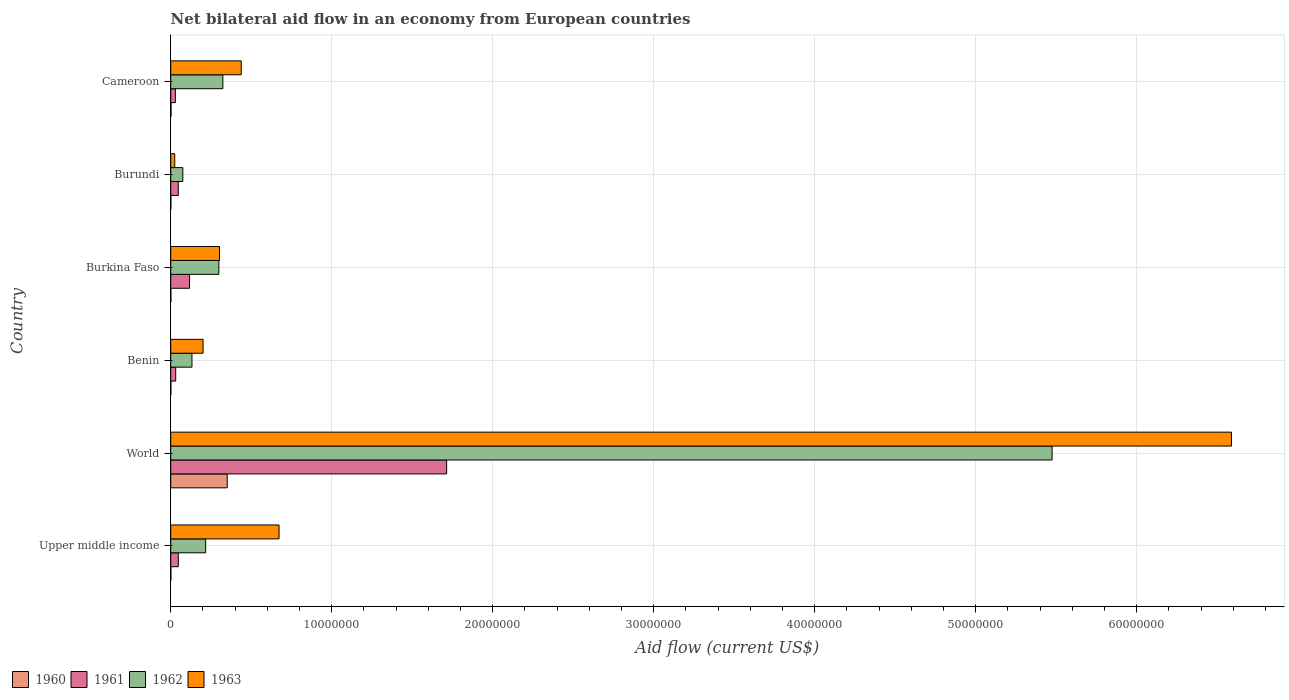How many groups of bars are there?
Offer a very short reply. 6. In how many cases, is the number of bars for a given country not equal to the number of legend labels?
Offer a very short reply. 0. Across all countries, what is the maximum net bilateral aid flow in 1961?
Provide a succinct answer. 1.71e+07. Across all countries, what is the minimum net bilateral aid flow in 1961?
Provide a short and direct response. 2.90e+05. In which country was the net bilateral aid flow in 1961 maximum?
Offer a very short reply. World. In which country was the net bilateral aid flow in 1963 minimum?
Ensure brevity in your answer.  Burundi. What is the total net bilateral aid flow in 1961 in the graph?
Offer a very short reply. 1.98e+07. What is the difference between the net bilateral aid flow in 1963 in Benin and that in Burkina Faso?
Make the answer very short. -1.02e+06. What is the difference between the net bilateral aid flow in 1961 in Burkina Faso and the net bilateral aid flow in 1960 in Upper middle income?
Provide a succinct answer. 1.16e+06. What is the average net bilateral aid flow in 1961 per country?
Make the answer very short. 3.31e+06. What is the difference between the net bilateral aid flow in 1963 and net bilateral aid flow in 1960 in Upper middle income?
Provide a succinct answer. 6.72e+06. In how many countries, is the net bilateral aid flow in 1962 greater than 60000000 US$?
Offer a terse response. 0. Is the difference between the net bilateral aid flow in 1963 in Cameroon and Upper middle income greater than the difference between the net bilateral aid flow in 1960 in Cameroon and Upper middle income?
Provide a succinct answer. No. What is the difference between the highest and the second highest net bilateral aid flow in 1961?
Offer a terse response. 1.60e+07. What is the difference between the highest and the lowest net bilateral aid flow in 1961?
Give a very brief answer. 1.68e+07. Is it the case that in every country, the sum of the net bilateral aid flow in 1963 and net bilateral aid flow in 1960 is greater than the sum of net bilateral aid flow in 1962 and net bilateral aid flow in 1961?
Your response must be concise. Yes. What does the 3rd bar from the top in Burundi represents?
Make the answer very short. 1961. What does the 1st bar from the bottom in World represents?
Ensure brevity in your answer.  1960. Is it the case that in every country, the sum of the net bilateral aid flow in 1961 and net bilateral aid flow in 1960 is greater than the net bilateral aid flow in 1963?
Provide a short and direct response. No. Are all the bars in the graph horizontal?
Your answer should be compact. Yes. How many countries are there in the graph?
Your answer should be compact. 6. What is the difference between two consecutive major ticks on the X-axis?
Offer a very short reply. 1.00e+07. Does the graph contain any zero values?
Give a very brief answer. No. Does the graph contain grids?
Offer a very short reply. Yes. Where does the legend appear in the graph?
Your response must be concise. Bottom left. How many legend labels are there?
Make the answer very short. 4. How are the legend labels stacked?
Ensure brevity in your answer.  Horizontal. What is the title of the graph?
Ensure brevity in your answer.  Net bilateral aid flow in an economy from European countries. What is the label or title of the Y-axis?
Your answer should be compact. Country. What is the Aid flow (current US$) of 1962 in Upper middle income?
Your response must be concise. 2.17e+06. What is the Aid flow (current US$) in 1963 in Upper middle income?
Provide a short and direct response. 6.73e+06. What is the Aid flow (current US$) of 1960 in World?
Your answer should be very brief. 3.51e+06. What is the Aid flow (current US$) in 1961 in World?
Provide a succinct answer. 1.71e+07. What is the Aid flow (current US$) of 1962 in World?
Ensure brevity in your answer.  5.48e+07. What is the Aid flow (current US$) of 1963 in World?
Give a very brief answer. 6.59e+07. What is the Aid flow (current US$) in 1962 in Benin?
Your response must be concise. 1.32e+06. What is the Aid flow (current US$) in 1963 in Benin?
Give a very brief answer. 2.01e+06. What is the Aid flow (current US$) in 1960 in Burkina Faso?
Make the answer very short. 10000. What is the Aid flow (current US$) of 1961 in Burkina Faso?
Your response must be concise. 1.17e+06. What is the Aid flow (current US$) of 1962 in Burkina Faso?
Make the answer very short. 2.99e+06. What is the Aid flow (current US$) in 1963 in Burkina Faso?
Give a very brief answer. 3.03e+06. What is the Aid flow (current US$) in 1960 in Burundi?
Offer a terse response. 10000. What is the Aid flow (current US$) of 1962 in Burundi?
Your answer should be compact. 7.50e+05. What is the Aid flow (current US$) in 1961 in Cameroon?
Give a very brief answer. 2.90e+05. What is the Aid flow (current US$) of 1962 in Cameroon?
Make the answer very short. 3.24e+06. What is the Aid flow (current US$) of 1963 in Cameroon?
Offer a terse response. 4.38e+06. Across all countries, what is the maximum Aid flow (current US$) of 1960?
Make the answer very short. 3.51e+06. Across all countries, what is the maximum Aid flow (current US$) in 1961?
Provide a short and direct response. 1.71e+07. Across all countries, what is the maximum Aid flow (current US$) of 1962?
Keep it short and to the point. 5.48e+07. Across all countries, what is the maximum Aid flow (current US$) in 1963?
Keep it short and to the point. 6.59e+07. Across all countries, what is the minimum Aid flow (current US$) of 1961?
Offer a very short reply. 2.90e+05. Across all countries, what is the minimum Aid flow (current US$) in 1962?
Keep it short and to the point. 7.50e+05. Across all countries, what is the minimum Aid flow (current US$) of 1963?
Ensure brevity in your answer.  2.50e+05. What is the total Aid flow (current US$) in 1960 in the graph?
Offer a terse response. 3.57e+06. What is the total Aid flow (current US$) of 1961 in the graph?
Your answer should be very brief. 1.98e+07. What is the total Aid flow (current US$) of 1962 in the graph?
Your response must be concise. 6.52e+07. What is the total Aid flow (current US$) of 1963 in the graph?
Your answer should be compact. 8.23e+07. What is the difference between the Aid flow (current US$) of 1960 in Upper middle income and that in World?
Your answer should be very brief. -3.50e+06. What is the difference between the Aid flow (current US$) of 1961 in Upper middle income and that in World?
Keep it short and to the point. -1.67e+07. What is the difference between the Aid flow (current US$) in 1962 in Upper middle income and that in World?
Your answer should be very brief. -5.26e+07. What is the difference between the Aid flow (current US$) of 1963 in Upper middle income and that in World?
Your response must be concise. -5.92e+07. What is the difference between the Aid flow (current US$) in 1960 in Upper middle income and that in Benin?
Your answer should be very brief. 0. What is the difference between the Aid flow (current US$) in 1962 in Upper middle income and that in Benin?
Ensure brevity in your answer.  8.50e+05. What is the difference between the Aid flow (current US$) of 1963 in Upper middle income and that in Benin?
Your response must be concise. 4.72e+06. What is the difference between the Aid flow (current US$) of 1961 in Upper middle income and that in Burkina Faso?
Ensure brevity in your answer.  -7.00e+05. What is the difference between the Aid flow (current US$) in 1962 in Upper middle income and that in Burkina Faso?
Ensure brevity in your answer.  -8.20e+05. What is the difference between the Aid flow (current US$) in 1963 in Upper middle income and that in Burkina Faso?
Offer a terse response. 3.70e+06. What is the difference between the Aid flow (current US$) in 1960 in Upper middle income and that in Burundi?
Your answer should be very brief. 0. What is the difference between the Aid flow (current US$) in 1962 in Upper middle income and that in Burundi?
Offer a very short reply. 1.42e+06. What is the difference between the Aid flow (current US$) of 1963 in Upper middle income and that in Burundi?
Give a very brief answer. 6.48e+06. What is the difference between the Aid flow (current US$) of 1961 in Upper middle income and that in Cameroon?
Keep it short and to the point. 1.80e+05. What is the difference between the Aid flow (current US$) in 1962 in Upper middle income and that in Cameroon?
Offer a very short reply. -1.07e+06. What is the difference between the Aid flow (current US$) in 1963 in Upper middle income and that in Cameroon?
Give a very brief answer. 2.35e+06. What is the difference between the Aid flow (current US$) in 1960 in World and that in Benin?
Provide a succinct answer. 3.50e+06. What is the difference between the Aid flow (current US$) in 1961 in World and that in Benin?
Make the answer very short. 1.68e+07. What is the difference between the Aid flow (current US$) of 1962 in World and that in Benin?
Provide a short and direct response. 5.34e+07. What is the difference between the Aid flow (current US$) of 1963 in World and that in Benin?
Your answer should be very brief. 6.39e+07. What is the difference between the Aid flow (current US$) in 1960 in World and that in Burkina Faso?
Your response must be concise. 3.50e+06. What is the difference between the Aid flow (current US$) in 1961 in World and that in Burkina Faso?
Ensure brevity in your answer.  1.60e+07. What is the difference between the Aid flow (current US$) of 1962 in World and that in Burkina Faso?
Ensure brevity in your answer.  5.18e+07. What is the difference between the Aid flow (current US$) in 1963 in World and that in Burkina Faso?
Keep it short and to the point. 6.29e+07. What is the difference between the Aid flow (current US$) in 1960 in World and that in Burundi?
Provide a succinct answer. 3.50e+06. What is the difference between the Aid flow (current US$) in 1961 in World and that in Burundi?
Give a very brief answer. 1.67e+07. What is the difference between the Aid flow (current US$) of 1962 in World and that in Burundi?
Make the answer very short. 5.40e+07. What is the difference between the Aid flow (current US$) of 1963 in World and that in Burundi?
Offer a very short reply. 6.56e+07. What is the difference between the Aid flow (current US$) of 1960 in World and that in Cameroon?
Offer a terse response. 3.49e+06. What is the difference between the Aid flow (current US$) in 1961 in World and that in Cameroon?
Provide a succinct answer. 1.68e+07. What is the difference between the Aid flow (current US$) of 1962 in World and that in Cameroon?
Your answer should be compact. 5.15e+07. What is the difference between the Aid flow (current US$) of 1963 in World and that in Cameroon?
Your response must be concise. 6.15e+07. What is the difference between the Aid flow (current US$) in 1960 in Benin and that in Burkina Faso?
Your answer should be compact. 0. What is the difference between the Aid flow (current US$) in 1961 in Benin and that in Burkina Faso?
Your response must be concise. -8.60e+05. What is the difference between the Aid flow (current US$) in 1962 in Benin and that in Burkina Faso?
Offer a terse response. -1.67e+06. What is the difference between the Aid flow (current US$) in 1963 in Benin and that in Burkina Faso?
Ensure brevity in your answer.  -1.02e+06. What is the difference between the Aid flow (current US$) in 1960 in Benin and that in Burundi?
Keep it short and to the point. 0. What is the difference between the Aid flow (current US$) of 1962 in Benin and that in Burundi?
Your response must be concise. 5.70e+05. What is the difference between the Aid flow (current US$) of 1963 in Benin and that in Burundi?
Make the answer very short. 1.76e+06. What is the difference between the Aid flow (current US$) of 1960 in Benin and that in Cameroon?
Offer a very short reply. -10000. What is the difference between the Aid flow (current US$) in 1962 in Benin and that in Cameroon?
Your answer should be very brief. -1.92e+06. What is the difference between the Aid flow (current US$) of 1963 in Benin and that in Cameroon?
Give a very brief answer. -2.37e+06. What is the difference between the Aid flow (current US$) in 1960 in Burkina Faso and that in Burundi?
Ensure brevity in your answer.  0. What is the difference between the Aid flow (current US$) in 1962 in Burkina Faso and that in Burundi?
Offer a terse response. 2.24e+06. What is the difference between the Aid flow (current US$) of 1963 in Burkina Faso and that in Burundi?
Your answer should be very brief. 2.78e+06. What is the difference between the Aid flow (current US$) of 1960 in Burkina Faso and that in Cameroon?
Make the answer very short. -10000. What is the difference between the Aid flow (current US$) in 1961 in Burkina Faso and that in Cameroon?
Provide a short and direct response. 8.80e+05. What is the difference between the Aid flow (current US$) in 1962 in Burkina Faso and that in Cameroon?
Your answer should be very brief. -2.50e+05. What is the difference between the Aid flow (current US$) in 1963 in Burkina Faso and that in Cameroon?
Your response must be concise. -1.35e+06. What is the difference between the Aid flow (current US$) of 1960 in Burundi and that in Cameroon?
Your answer should be compact. -10000. What is the difference between the Aid flow (current US$) of 1961 in Burundi and that in Cameroon?
Provide a succinct answer. 1.80e+05. What is the difference between the Aid flow (current US$) in 1962 in Burundi and that in Cameroon?
Provide a succinct answer. -2.49e+06. What is the difference between the Aid flow (current US$) of 1963 in Burundi and that in Cameroon?
Give a very brief answer. -4.13e+06. What is the difference between the Aid flow (current US$) of 1960 in Upper middle income and the Aid flow (current US$) of 1961 in World?
Offer a terse response. -1.71e+07. What is the difference between the Aid flow (current US$) in 1960 in Upper middle income and the Aid flow (current US$) in 1962 in World?
Provide a short and direct response. -5.47e+07. What is the difference between the Aid flow (current US$) of 1960 in Upper middle income and the Aid flow (current US$) of 1963 in World?
Make the answer very short. -6.59e+07. What is the difference between the Aid flow (current US$) in 1961 in Upper middle income and the Aid flow (current US$) in 1962 in World?
Your answer should be compact. -5.43e+07. What is the difference between the Aid flow (current US$) in 1961 in Upper middle income and the Aid flow (current US$) in 1963 in World?
Give a very brief answer. -6.54e+07. What is the difference between the Aid flow (current US$) of 1962 in Upper middle income and the Aid flow (current US$) of 1963 in World?
Keep it short and to the point. -6.37e+07. What is the difference between the Aid flow (current US$) of 1960 in Upper middle income and the Aid flow (current US$) of 1961 in Benin?
Offer a very short reply. -3.00e+05. What is the difference between the Aid flow (current US$) of 1960 in Upper middle income and the Aid flow (current US$) of 1962 in Benin?
Ensure brevity in your answer.  -1.31e+06. What is the difference between the Aid flow (current US$) of 1960 in Upper middle income and the Aid flow (current US$) of 1963 in Benin?
Offer a very short reply. -2.00e+06. What is the difference between the Aid flow (current US$) in 1961 in Upper middle income and the Aid flow (current US$) in 1962 in Benin?
Your answer should be very brief. -8.50e+05. What is the difference between the Aid flow (current US$) of 1961 in Upper middle income and the Aid flow (current US$) of 1963 in Benin?
Provide a succinct answer. -1.54e+06. What is the difference between the Aid flow (current US$) of 1962 in Upper middle income and the Aid flow (current US$) of 1963 in Benin?
Offer a terse response. 1.60e+05. What is the difference between the Aid flow (current US$) in 1960 in Upper middle income and the Aid flow (current US$) in 1961 in Burkina Faso?
Give a very brief answer. -1.16e+06. What is the difference between the Aid flow (current US$) in 1960 in Upper middle income and the Aid flow (current US$) in 1962 in Burkina Faso?
Provide a short and direct response. -2.98e+06. What is the difference between the Aid flow (current US$) of 1960 in Upper middle income and the Aid flow (current US$) of 1963 in Burkina Faso?
Keep it short and to the point. -3.02e+06. What is the difference between the Aid flow (current US$) of 1961 in Upper middle income and the Aid flow (current US$) of 1962 in Burkina Faso?
Provide a short and direct response. -2.52e+06. What is the difference between the Aid flow (current US$) of 1961 in Upper middle income and the Aid flow (current US$) of 1963 in Burkina Faso?
Give a very brief answer. -2.56e+06. What is the difference between the Aid flow (current US$) in 1962 in Upper middle income and the Aid flow (current US$) in 1963 in Burkina Faso?
Make the answer very short. -8.60e+05. What is the difference between the Aid flow (current US$) in 1960 in Upper middle income and the Aid flow (current US$) in 1961 in Burundi?
Give a very brief answer. -4.60e+05. What is the difference between the Aid flow (current US$) in 1960 in Upper middle income and the Aid flow (current US$) in 1962 in Burundi?
Keep it short and to the point. -7.40e+05. What is the difference between the Aid flow (current US$) in 1961 in Upper middle income and the Aid flow (current US$) in 1962 in Burundi?
Offer a terse response. -2.80e+05. What is the difference between the Aid flow (current US$) of 1961 in Upper middle income and the Aid flow (current US$) of 1963 in Burundi?
Provide a short and direct response. 2.20e+05. What is the difference between the Aid flow (current US$) of 1962 in Upper middle income and the Aid flow (current US$) of 1963 in Burundi?
Offer a terse response. 1.92e+06. What is the difference between the Aid flow (current US$) in 1960 in Upper middle income and the Aid flow (current US$) in 1961 in Cameroon?
Your answer should be very brief. -2.80e+05. What is the difference between the Aid flow (current US$) in 1960 in Upper middle income and the Aid flow (current US$) in 1962 in Cameroon?
Ensure brevity in your answer.  -3.23e+06. What is the difference between the Aid flow (current US$) of 1960 in Upper middle income and the Aid flow (current US$) of 1963 in Cameroon?
Provide a short and direct response. -4.37e+06. What is the difference between the Aid flow (current US$) of 1961 in Upper middle income and the Aid flow (current US$) of 1962 in Cameroon?
Your response must be concise. -2.77e+06. What is the difference between the Aid flow (current US$) of 1961 in Upper middle income and the Aid flow (current US$) of 1963 in Cameroon?
Give a very brief answer. -3.91e+06. What is the difference between the Aid flow (current US$) in 1962 in Upper middle income and the Aid flow (current US$) in 1963 in Cameroon?
Ensure brevity in your answer.  -2.21e+06. What is the difference between the Aid flow (current US$) in 1960 in World and the Aid flow (current US$) in 1961 in Benin?
Provide a short and direct response. 3.20e+06. What is the difference between the Aid flow (current US$) of 1960 in World and the Aid flow (current US$) of 1962 in Benin?
Offer a terse response. 2.19e+06. What is the difference between the Aid flow (current US$) in 1960 in World and the Aid flow (current US$) in 1963 in Benin?
Offer a terse response. 1.50e+06. What is the difference between the Aid flow (current US$) in 1961 in World and the Aid flow (current US$) in 1962 in Benin?
Your answer should be very brief. 1.58e+07. What is the difference between the Aid flow (current US$) in 1961 in World and the Aid flow (current US$) in 1963 in Benin?
Ensure brevity in your answer.  1.51e+07. What is the difference between the Aid flow (current US$) of 1962 in World and the Aid flow (current US$) of 1963 in Benin?
Your response must be concise. 5.27e+07. What is the difference between the Aid flow (current US$) of 1960 in World and the Aid flow (current US$) of 1961 in Burkina Faso?
Ensure brevity in your answer.  2.34e+06. What is the difference between the Aid flow (current US$) in 1960 in World and the Aid flow (current US$) in 1962 in Burkina Faso?
Your answer should be compact. 5.20e+05. What is the difference between the Aid flow (current US$) in 1960 in World and the Aid flow (current US$) in 1963 in Burkina Faso?
Your response must be concise. 4.80e+05. What is the difference between the Aid flow (current US$) in 1961 in World and the Aid flow (current US$) in 1962 in Burkina Faso?
Your response must be concise. 1.42e+07. What is the difference between the Aid flow (current US$) in 1961 in World and the Aid flow (current US$) in 1963 in Burkina Faso?
Ensure brevity in your answer.  1.41e+07. What is the difference between the Aid flow (current US$) of 1962 in World and the Aid flow (current US$) of 1963 in Burkina Faso?
Provide a succinct answer. 5.17e+07. What is the difference between the Aid flow (current US$) of 1960 in World and the Aid flow (current US$) of 1961 in Burundi?
Offer a terse response. 3.04e+06. What is the difference between the Aid flow (current US$) of 1960 in World and the Aid flow (current US$) of 1962 in Burundi?
Ensure brevity in your answer.  2.76e+06. What is the difference between the Aid flow (current US$) in 1960 in World and the Aid flow (current US$) in 1963 in Burundi?
Provide a short and direct response. 3.26e+06. What is the difference between the Aid flow (current US$) in 1961 in World and the Aid flow (current US$) in 1962 in Burundi?
Your answer should be very brief. 1.64e+07. What is the difference between the Aid flow (current US$) in 1961 in World and the Aid flow (current US$) in 1963 in Burundi?
Make the answer very short. 1.69e+07. What is the difference between the Aid flow (current US$) of 1962 in World and the Aid flow (current US$) of 1963 in Burundi?
Make the answer very short. 5.45e+07. What is the difference between the Aid flow (current US$) of 1960 in World and the Aid flow (current US$) of 1961 in Cameroon?
Your answer should be compact. 3.22e+06. What is the difference between the Aid flow (current US$) of 1960 in World and the Aid flow (current US$) of 1962 in Cameroon?
Provide a short and direct response. 2.70e+05. What is the difference between the Aid flow (current US$) of 1960 in World and the Aid flow (current US$) of 1963 in Cameroon?
Offer a terse response. -8.70e+05. What is the difference between the Aid flow (current US$) of 1961 in World and the Aid flow (current US$) of 1962 in Cameroon?
Provide a short and direct response. 1.39e+07. What is the difference between the Aid flow (current US$) of 1961 in World and the Aid flow (current US$) of 1963 in Cameroon?
Offer a very short reply. 1.28e+07. What is the difference between the Aid flow (current US$) in 1962 in World and the Aid flow (current US$) in 1963 in Cameroon?
Give a very brief answer. 5.04e+07. What is the difference between the Aid flow (current US$) of 1960 in Benin and the Aid flow (current US$) of 1961 in Burkina Faso?
Provide a succinct answer. -1.16e+06. What is the difference between the Aid flow (current US$) of 1960 in Benin and the Aid flow (current US$) of 1962 in Burkina Faso?
Ensure brevity in your answer.  -2.98e+06. What is the difference between the Aid flow (current US$) of 1960 in Benin and the Aid flow (current US$) of 1963 in Burkina Faso?
Make the answer very short. -3.02e+06. What is the difference between the Aid flow (current US$) in 1961 in Benin and the Aid flow (current US$) in 1962 in Burkina Faso?
Offer a terse response. -2.68e+06. What is the difference between the Aid flow (current US$) in 1961 in Benin and the Aid flow (current US$) in 1963 in Burkina Faso?
Keep it short and to the point. -2.72e+06. What is the difference between the Aid flow (current US$) of 1962 in Benin and the Aid flow (current US$) of 1963 in Burkina Faso?
Your answer should be compact. -1.71e+06. What is the difference between the Aid flow (current US$) of 1960 in Benin and the Aid flow (current US$) of 1961 in Burundi?
Your answer should be compact. -4.60e+05. What is the difference between the Aid flow (current US$) of 1960 in Benin and the Aid flow (current US$) of 1962 in Burundi?
Offer a very short reply. -7.40e+05. What is the difference between the Aid flow (current US$) of 1961 in Benin and the Aid flow (current US$) of 1962 in Burundi?
Make the answer very short. -4.40e+05. What is the difference between the Aid flow (current US$) in 1961 in Benin and the Aid flow (current US$) in 1963 in Burundi?
Offer a very short reply. 6.00e+04. What is the difference between the Aid flow (current US$) in 1962 in Benin and the Aid flow (current US$) in 1963 in Burundi?
Offer a terse response. 1.07e+06. What is the difference between the Aid flow (current US$) of 1960 in Benin and the Aid flow (current US$) of 1961 in Cameroon?
Your answer should be very brief. -2.80e+05. What is the difference between the Aid flow (current US$) of 1960 in Benin and the Aid flow (current US$) of 1962 in Cameroon?
Make the answer very short. -3.23e+06. What is the difference between the Aid flow (current US$) in 1960 in Benin and the Aid flow (current US$) in 1963 in Cameroon?
Offer a very short reply. -4.37e+06. What is the difference between the Aid flow (current US$) of 1961 in Benin and the Aid flow (current US$) of 1962 in Cameroon?
Offer a very short reply. -2.93e+06. What is the difference between the Aid flow (current US$) of 1961 in Benin and the Aid flow (current US$) of 1963 in Cameroon?
Provide a short and direct response. -4.07e+06. What is the difference between the Aid flow (current US$) in 1962 in Benin and the Aid flow (current US$) in 1963 in Cameroon?
Your response must be concise. -3.06e+06. What is the difference between the Aid flow (current US$) of 1960 in Burkina Faso and the Aid flow (current US$) of 1961 in Burundi?
Give a very brief answer. -4.60e+05. What is the difference between the Aid flow (current US$) in 1960 in Burkina Faso and the Aid flow (current US$) in 1962 in Burundi?
Keep it short and to the point. -7.40e+05. What is the difference between the Aid flow (current US$) of 1960 in Burkina Faso and the Aid flow (current US$) of 1963 in Burundi?
Your answer should be compact. -2.40e+05. What is the difference between the Aid flow (current US$) in 1961 in Burkina Faso and the Aid flow (current US$) in 1962 in Burundi?
Your response must be concise. 4.20e+05. What is the difference between the Aid flow (current US$) of 1961 in Burkina Faso and the Aid flow (current US$) of 1963 in Burundi?
Keep it short and to the point. 9.20e+05. What is the difference between the Aid flow (current US$) of 1962 in Burkina Faso and the Aid flow (current US$) of 1963 in Burundi?
Keep it short and to the point. 2.74e+06. What is the difference between the Aid flow (current US$) of 1960 in Burkina Faso and the Aid flow (current US$) of 1961 in Cameroon?
Your response must be concise. -2.80e+05. What is the difference between the Aid flow (current US$) in 1960 in Burkina Faso and the Aid flow (current US$) in 1962 in Cameroon?
Your response must be concise. -3.23e+06. What is the difference between the Aid flow (current US$) of 1960 in Burkina Faso and the Aid flow (current US$) of 1963 in Cameroon?
Your answer should be compact. -4.37e+06. What is the difference between the Aid flow (current US$) in 1961 in Burkina Faso and the Aid flow (current US$) in 1962 in Cameroon?
Ensure brevity in your answer.  -2.07e+06. What is the difference between the Aid flow (current US$) in 1961 in Burkina Faso and the Aid flow (current US$) in 1963 in Cameroon?
Keep it short and to the point. -3.21e+06. What is the difference between the Aid flow (current US$) in 1962 in Burkina Faso and the Aid flow (current US$) in 1963 in Cameroon?
Give a very brief answer. -1.39e+06. What is the difference between the Aid flow (current US$) in 1960 in Burundi and the Aid flow (current US$) in 1961 in Cameroon?
Keep it short and to the point. -2.80e+05. What is the difference between the Aid flow (current US$) of 1960 in Burundi and the Aid flow (current US$) of 1962 in Cameroon?
Provide a succinct answer. -3.23e+06. What is the difference between the Aid flow (current US$) in 1960 in Burundi and the Aid flow (current US$) in 1963 in Cameroon?
Provide a succinct answer. -4.37e+06. What is the difference between the Aid flow (current US$) in 1961 in Burundi and the Aid flow (current US$) in 1962 in Cameroon?
Make the answer very short. -2.77e+06. What is the difference between the Aid flow (current US$) of 1961 in Burundi and the Aid flow (current US$) of 1963 in Cameroon?
Offer a very short reply. -3.91e+06. What is the difference between the Aid flow (current US$) in 1962 in Burundi and the Aid flow (current US$) in 1963 in Cameroon?
Give a very brief answer. -3.63e+06. What is the average Aid flow (current US$) in 1960 per country?
Ensure brevity in your answer.  5.95e+05. What is the average Aid flow (current US$) of 1961 per country?
Offer a very short reply. 3.31e+06. What is the average Aid flow (current US$) of 1962 per country?
Offer a very short reply. 1.09e+07. What is the average Aid flow (current US$) of 1963 per country?
Provide a succinct answer. 1.37e+07. What is the difference between the Aid flow (current US$) in 1960 and Aid flow (current US$) in 1961 in Upper middle income?
Offer a terse response. -4.60e+05. What is the difference between the Aid flow (current US$) in 1960 and Aid flow (current US$) in 1962 in Upper middle income?
Provide a short and direct response. -2.16e+06. What is the difference between the Aid flow (current US$) of 1960 and Aid flow (current US$) of 1963 in Upper middle income?
Make the answer very short. -6.72e+06. What is the difference between the Aid flow (current US$) of 1961 and Aid flow (current US$) of 1962 in Upper middle income?
Make the answer very short. -1.70e+06. What is the difference between the Aid flow (current US$) of 1961 and Aid flow (current US$) of 1963 in Upper middle income?
Your answer should be compact. -6.26e+06. What is the difference between the Aid flow (current US$) in 1962 and Aid flow (current US$) in 1963 in Upper middle income?
Offer a very short reply. -4.56e+06. What is the difference between the Aid flow (current US$) of 1960 and Aid flow (current US$) of 1961 in World?
Offer a terse response. -1.36e+07. What is the difference between the Aid flow (current US$) of 1960 and Aid flow (current US$) of 1962 in World?
Give a very brief answer. -5.12e+07. What is the difference between the Aid flow (current US$) in 1960 and Aid flow (current US$) in 1963 in World?
Make the answer very short. -6.24e+07. What is the difference between the Aid flow (current US$) of 1961 and Aid flow (current US$) of 1962 in World?
Provide a short and direct response. -3.76e+07. What is the difference between the Aid flow (current US$) in 1961 and Aid flow (current US$) in 1963 in World?
Offer a terse response. -4.88e+07. What is the difference between the Aid flow (current US$) in 1962 and Aid flow (current US$) in 1963 in World?
Offer a terse response. -1.11e+07. What is the difference between the Aid flow (current US$) in 1960 and Aid flow (current US$) in 1962 in Benin?
Give a very brief answer. -1.31e+06. What is the difference between the Aid flow (current US$) in 1961 and Aid flow (current US$) in 1962 in Benin?
Provide a short and direct response. -1.01e+06. What is the difference between the Aid flow (current US$) of 1961 and Aid flow (current US$) of 1963 in Benin?
Your answer should be compact. -1.70e+06. What is the difference between the Aid flow (current US$) of 1962 and Aid flow (current US$) of 1963 in Benin?
Your answer should be compact. -6.90e+05. What is the difference between the Aid flow (current US$) in 1960 and Aid flow (current US$) in 1961 in Burkina Faso?
Make the answer very short. -1.16e+06. What is the difference between the Aid flow (current US$) of 1960 and Aid flow (current US$) of 1962 in Burkina Faso?
Offer a very short reply. -2.98e+06. What is the difference between the Aid flow (current US$) of 1960 and Aid flow (current US$) of 1963 in Burkina Faso?
Your answer should be compact. -3.02e+06. What is the difference between the Aid flow (current US$) in 1961 and Aid flow (current US$) in 1962 in Burkina Faso?
Provide a short and direct response. -1.82e+06. What is the difference between the Aid flow (current US$) in 1961 and Aid flow (current US$) in 1963 in Burkina Faso?
Keep it short and to the point. -1.86e+06. What is the difference between the Aid flow (current US$) of 1960 and Aid flow (current US$) of 1961 in Burundi?
Give a very brief answer. -4.60e+05. What is the difference between the Aid flow (current US$) in 1960 and Aid flow (current US$) in 1962 in Burundi?
Keep it short and to the point. -7.40e+05. What is the difference between the Aid flow (current US$) of 1961 and Aid flow (current US$) of 1962 in Burundi?
Provide a succinct answer. -2.80e+05. What is the difference between the Aid flow (current US$) in 1961 and Aid flow (current US$) in 1963 in Burundi?
Provide a short and direct response. 2.20e+05. What is the difference between the Aid flow (current US$) of 1962 and Aid flow (current US$) of 1963 in Burundi?
Make the answer very short. 5.00e+05. What is the difference between the Aid flow (current US$) of 1960 and Aid flow (current US$) of 1962 in Cameroon?
Ensure brevity in your answer.  -3.22e+06. What is the difference between the Aid flow (current US$) of 1960 and Aid flow (current US$) of 1963 in Cameroon?
Offer a terse response. -4.36e+06. What is the difference between the Aid flow (current US$) in 1961 and Aid flow (current US$) in 1962 in Cameroon?
Make the answer very short. -2.95e+06. What is the difference between the Aid flow (current US$) of 1961 and Aid flow (current US$) of 1963 in Cameroon?
Give a very brief answer. -4.09e+06. What is the difference between the Aid flow (current US$) of 1962 and Aid flow (current US$) of 1963 in Cameroon?
Give a very brief answer. -1.14e+06. What is the ratio of the Aid flow (current US$) of 1960 in Upper middle income to that in World?
Offer a very short reply. 0. What is the ratio of the Aid flow (current US$) of 1961 in Upper middle income to that in World?
Your answer should be very brief. 0.03. What is the ratio of the Aid flow (current US$) in 1962 in Upper middle income to that in World?
Provide a succinct answer. 0.04. What is the ratio of the Aid flow (current US$) in 1963 in Upper middle income to that in World?
Make the answer very short. 0.1. What is the ratio of the Aid flow (current US$) of 1961 in Upper middle income to that in Benin?
Your answer should be compact. 1.52. What is the ratio of the Aid flow (current US$) in 1962 in Upper middle income to that in Benin?
Keep it short and to the point. 1.64. What is the ratio of the Aid flow (current US$) of 1963 in Upper middle income to that in Benin?
Give a very brief answer. 3.35. What is the ratio of the Aid flow (current US$) in 1961 in Upper middle income to that in Burkina Faso?
Make the answer very short. 0.4. What is the ratio of the Aid flow (current US$) in 1962 in Upper middle income to that in Burkina Faso?
Your answer should be very brief. 0.73. What is the ratio of the Aid flow (current US$) in 1963 in Upper middle income to that in Burkina Faso?
Provide a short and direct response. 2.22. What is the ratio of the Aid flow (current US$) of 1960 in Upper middle income to that in Burundi?
Provide a succinct answer. 1. What is the ratio of the Aid flow (current US$) in 1962 in Upper middle income to that in Burundi?
Offer a very short reply. 2.89. What is the ratio of the Aid flow (current US$) in 1963 in Upper middle income to that in Burundi?
Give a very brief answer. 26.92. What is the ratio of the Aid flow (current US$) in 1960 in Upper middle income to that in Cameroon?
Offer a terse response. 0.5. What is the ratio of the Aid flow (current US$) of 1961 in Upper middle income to that in Cameroon?
Ensure brevity in your answer.  1.62. What is the ratio of the Aid flow (current US$) of 1962 in Upper middle income to that in Cameroon?
Ensure brevity in your answer.  0.67. What is the ratio of the Aid flow (current US$) in 1963 in Upper middle income to that in Cameroon?
Provide a short and direct response. 1.54. What is the ratio of the Aid flow (current US$) in 1960 in World to that in Benin?
Keep it short and to the point. 351. What is the ratio of the Aid flow (current US$) in 1961 in World to that in Benin?
Provide a succinct answer. 55.29. What is the ratio of the Aid flow (current US$) in 1962 in World to that in Benin?
Keep it short and to the point. 41.48. What is the ratio of the Aid flow (current US$) of 1963 in World to that in Benin?
Your answer should be compact. 32.78. What is the ratio of the Aid flow (current US$) of 1960 in World to that in Burkina Faso?
Offer a very short reply. 351. What is the ratio of the Aid flow (current US$) in 1961 in World to that in Burkina Faso?
Your answer should be compact. 14.65. What is the ratio of the Aid flow (current US$) of 1962 in World to that in Burkina Faso?
Your response must be concise. 18.31. What is the ratio of the Aid flow (current US$) of 1963 in World to that in Burkina Faso?
Make the answer very short. 21.75. What is the ratio of the Aid flow (current US$) in 1960 in World to that in Burundi?
Keep it short and to the point. 351. What is the ratio of the Aid flow (current US$) in 1961 in World to that in Burundi?
Your answer should be very brief. 36.47. What is the ratio of the Aid flow (current US$) of 1962 in World to that in Burundi?
Keep it short and to the point. 73. What is the ratio of the Aid flow (current US$) of 1963 in World to that in Burundi?
Ensure brevity in your answer.  263.56. What is the ratio of the Aid flow (current US$) of 1960 in World to that in Cameroon?
Provide a short and direct response. 175.5. What is the ratio of the Aid flow (current US$) of 1961 in World to that in Cameroon?
Your answer should be very brief. 59.1. What is the ratio of the Aid flow (current US$) in 1962 in World to that in Cameroon?
Make the answer very short. 16.9. What is the ratio of the Aid flow (current US$) of 1963 in World to that in Cameroon?
Give a very brief answer. 15.04. What is the ratio of the Aid flow (current US$) of 1961 in Benin to that in Burkina Faso?
Ensure brevity in your answer.  0.27. What is the ratio of the Aid flow (current US$) in 1962 in Benin to that in Burkina Faso?
Ensure brevity in your answer.  0.44. What is the ratio of the Aid flow (current US$) of 1963 in Benin to that in Burkina Faso?
Offer a terse response. 0.66. What is the ratio of the Aid flow (current US$) of 1960 in Benin to that in Burundi?
Offer a very short reply. 1. What is the ratio of the Aid flow (current US$) of 1961 in Benin to that in Burundi?
Ensure brevity in your answer.  0.66. What is the ratio of the Aid flow (current US$) in 1962 in Benin to that in Burundi?
Your answer should be compact. 1.76. What is the ratio of the Aid flow (current US$) of 1963 in Benin to that in Burundi?
Ensure brevity in your answer.  8.04. What is the ratio of the Aid flow (current US$) of 1961 in Benin to that in Cameroon?
Ensure brevity in your answer.  1.07. What is the ratio of the Aid flow (current US$) of 1962 in Benin to that in Cameroon?
Offer a terse response. 0.41. What is the ratio of the Aid flow (current US$) in 1963 in Benin to that in Cameroon?
Give a very brief answer. 0.46. What is the ratio of the Aid flow (current US$) in 1961 in Burkina Faso to that in Burundi?
Give a very brief answer. 2.49. What is the ratio of the Aid flow (current US$) of 1962 in Burkina Faso to that in Burundi?
Give a very brief answer. 3.99. What is the ratio of the Aid flow (current US$) in 1963 in Burkina Faso to that in Burundi?
Offer a very short reply. 12.12. What is the ratio of the Aid flow (current US$) in 1960 in Burkina Faso to that in Cameroon?
Offer a terse response. 0.5. What is the ratio of the Aid flow (current US$) of 1961 in Burkina Faso to that in Cameroon?
Your answer should be compact. 4.03. What is the ratio of the Aid flow (current US$) in 1962 in Burkina Faso to that in Cameroon?
Your answer should be compact. 0.92. What is the ratio of the Aid flow (current US$) in 1963 in Burkina Faso to that in Cameroon?
Your response must be concise. 0.69. What is the ratio of the Aid flow (current US$) of 1961 in Burundi to that in Cameroon?
Make the answer very short. 1.62. What is the ratio of the Aid flow (current US$) in 1962 in Burundi to that in Cameroon?
Give a very brief answer. 0.23. What is the ratio of the Aid flow (current US$) in 1963 in Burundi to that in Cameroon?
Offer a terse response. 0.06. What is the difference between the highest and the second highest Aid flow (current US$) in 1960?
Provide a succinct answer. 3.49e+06. What is the difference between the highest and the second highest Aid flow (current US$) of 1961?
Give a very brief answer. 1.60e+07. What is the difference between the highest and the second highest Aid flow (current US$) in 1962?
Your answer should be very brief. 5.15e+07. What is the difference between the highest and the second highest Aid flow (current US$) of 1963?
Make the answer very short. 5.92e+07. What is the difference between the highest and the lowest Aid flow (current US$) in 1960?
Your answer should be compact. 3.50e+06. What is the difference between the highest and the lowest Aid flow (current US$) in 1961?
Make the answer very short. 1.68e+07. What is the difference between the highest and the lowest Aid flow (current US$) in 1962?
Your response must be concise. 5.40e+07. What is the difference between the highest and the lowest Aid flow (current US$) in 1963?
Your answer should be very brief. 6.56e+07. 